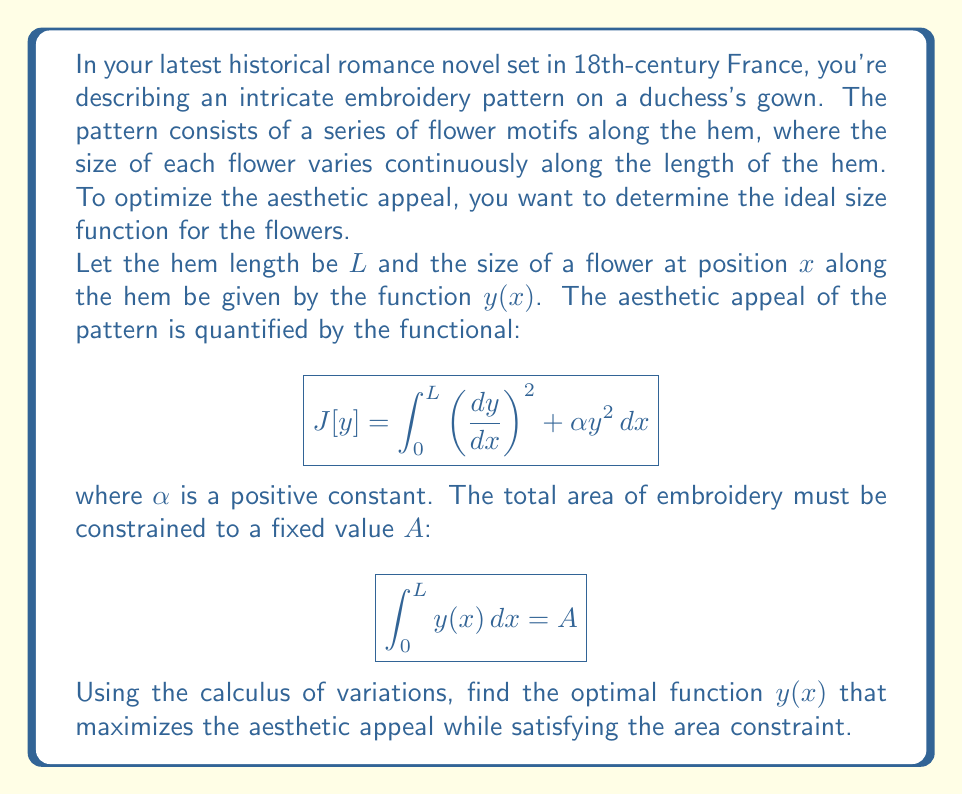Can you answer this question? To solve this problem, we'll use the Euler-Lagrange equation with an isoperimetric constraint. Here's the step-by-step solution:

1) First, we form the augmented functional with a Lagrange multiplier $\lambda$:

   $$\tilde{J}[y] = \int_0^L \left[\left(\frac{dy}{dx}\right)^2 + \alpha y^2 + \lambda y\right] \,dx$$

2) The Euler-Lagrange equation for this functional is:

   $$\frac{\partial F}{\partial y} - \frac{d}{dx}\left(\frac{\partial F}{\partial y'}\right) = 0$$

   where $F = \left(\frac{dy}{dx}\right)^2 + \alpha y^2 + \lambda y$

3) Calculating the partial derivatives:

   $$\frac{\partial F}{\partial y} = 2\alpha y + \lambda$$
   $$\frac{\partial F}{\partial y'} = 2\frac{dy}{dx}$$

4) Substituting into the Euler-Lagrange equation:

   $$2\alpha y + \lambda - \frac{d}{dx}\left(2\frac{dy}{dx}\right) = 0$$

5) Simplifying:

   $$2\alpha y + \lambda - 2\frac{d^2y}{dx^2} = 0$$
   $$\frac{d^2y}{dx^2} - \alpha y = \frac{\lambda}{2}$$

6) This is a second-order linear differential equation. The general solution is:

   $$y(x) = C_1 e^{\sqrt{\alpha}x} + C_2 e^{-\sqrt{\alpha}x} + \frac{\lambda}{2\alpha}$$

7) To determine the constants, we need boundary conditions. Given the symmetry of the problem, we can assume $y(0) = y(L)$. This gives us:

   $$C_1 + C_2 + \frac{\lambda}{2\alpha} = C_1 e^{\sqrt{\alpha}L} + C_2 e^{-\sqrt{\alpha}L} + \frac{\lambda}{2\alpha}$$

8) Solving this along with the area constraint:

   $$\int_0^L y(x) \,dx = A$$

   will determine the values of $C_1$, $C_2$, and $\lambda$.

9) The solution that satisfies these conditions is:

   $$y(x) = \frac{A}{L} + B \cos\left(\frac{2\pi x}{L}\right)$$

   where $B$ is a constant determined by $\alpha$ and $L$.
Answer: The optimal function for the flower size along the hem is:

$$y(x) = \frac{A}{L} + B \cos\left(\frac{2\pi x}{L}\right)$$

where $A$ is the total area of embroidery, $L$ is the length of the hem, and $B$ is a constant determined by the problem parameters. 